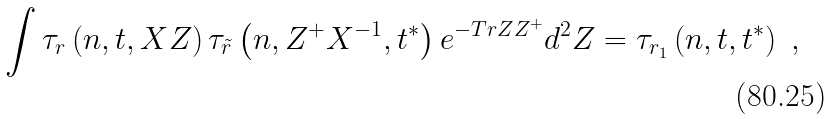<formula> <loc_0><loc_0><loc_500><loc_500>\int \tau _ { r } \left ( n , { t } , X Z \right ) \tau _ { \tilde { r } } \left ( n , Z ^ { + } X ^ { - 1 } , { t } ^ { * } \right ) e ^ { - T r Z Z ^ { + } } d ^ { 2 } Z = \tau _ { r _ { 1 } } \left ( n , { t } , { t } ^ { * } \right ) \ ,</formula> 